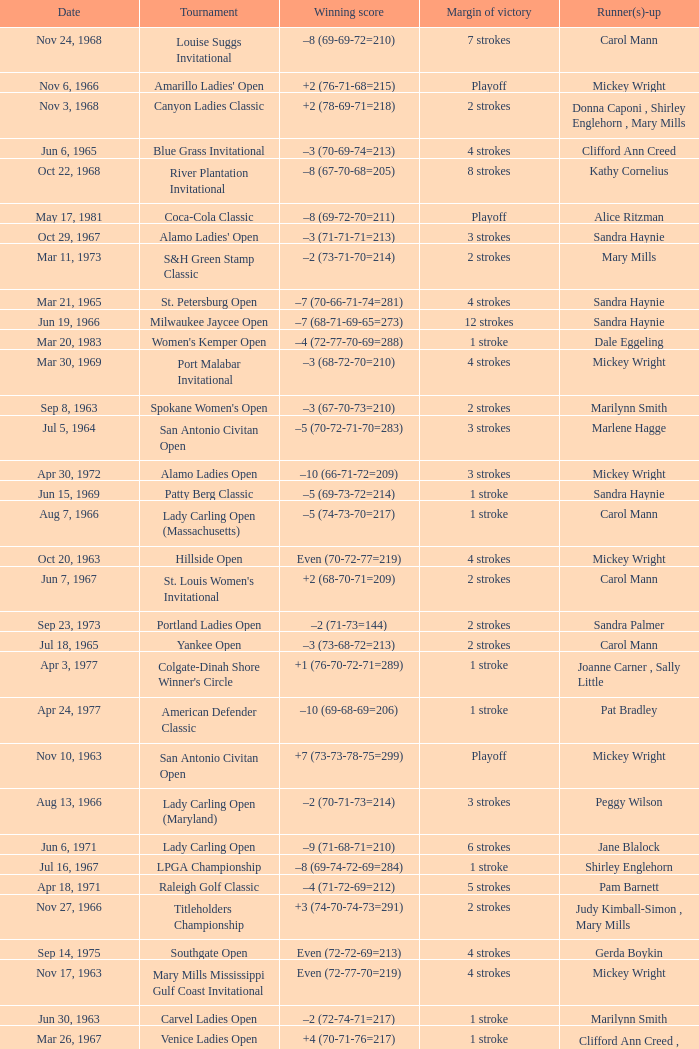Parse the table in full. {'header': ['Date', 'Tournament', 'Winning score', 'Margin of victory', 'Runner(s)-up'], 'rows': [['Nov 24, 1968', 'Louise Suggs Invitational', '–8 (69-69-72=210)', '7 strokes', 'Carol Mann'], ['Nov 6, 1966', "Amarillo Ladies' Open", '+2 (76-71-68=215)', 'Playoff', 'Mickey Wright'], ['Nov 3, 1968', 'Canyon Ladies Classic', '+2 (78-69-71=218)', '2 strokes', 'Donna Caponi , Shirley Englehorn , Mary Mills'], ['Jun 6, 1965', 'Blue Grass Invitational', '–3 (70-69-74=213)', '4 strokes', 'Clifford Ann Creed'], ['Oct 22, 1968', 'River Plantation Invitational', '–8 (67-70-68=205)', '8 strokes', 'Kathy Cornelius'], ['May 17, 1981', 'Coca-Cola Classic', '–8 (69-72-70=211)', 'Playoff', 'Alice Ritzman'], ['Oct 29, 1967', "Alamo Ladies' Open", '–3 (71-71-71=213)', '3 strokes', 'Sandra Haynie'], ['Mar 11, 1973', 'S&H Green Stamp Classic', '–2 (73-71-70=214)', '2 strokes', 'Mary Mills'], ['Mar 21, 1965', 'St. Petersburg Open', '–7 (70-66-71-74=281)', '4 strokes', 'Sandra Haynie'], ['Jun 19, 1966', 'Milwaukee Jaycee Open', '–7 (68-71-69-65=273)', '12 strokes', 'Sandra Haynie'], ['Mar 20, 1983', "Women's Kemper Open", '–4 (72-77-70-69=288)', '1 stroke', 'Dale Eggeling'], ['Mar 30, 1969', 'Port Malabar Invitational', '–3 (68-72-70=210)', '4 strokes', 'Mickey Wright'], ['Sep 8, 1963', "Spokane Women's Open", '–3 (67-70-73=210)', '2 strokes', 'Marilynn Smith'], ['Jul 5, 1964', 'San Antonio Civitan Open', '–5 (70-72-71-70=283)', '3 strokes', 'Marlene Hagge'], ['Apr 30, 1972', 'Alamo Ladies Open', '–10 (66-71-72=209)', '3 strokes', 'Mickey Wright'], ['Jun 15, 1969', 'Patty Berg Classic', '–5 (69-73-72=214)', '1 stroke', 'Sandra Haynie'], ['Aug 7, 1966', 'Lady Carling Open (Massachusetts)', '–5 (74-73-70=217)', '1 stroke', 'Carol Mann'], ['Oct 20, 1963', 'Hillside Open', 'Even (70-72-77=219)', '4 strokes', 'Mickey Wright'], ['Jun 7, 1967', "St. Louis Women's Invitational", '+2 (68-70-71=209)', '2 strokes', 'Carol Mann'], ['Sep 23, 1973', 'Portland Ladies Open', '–2 (71-73=144)', '2 strokes', 'Sandra Palmer'], ['Jul 18, 1965', 'Yankee Open', '–3 (73-68-72=213)', '2 strokes', 'Carol Mann'], ['Apr 3, 1977', "Colgate-Dinah Shore Winner's Circle", '+1 (76-70-72-71=289)', '1 stroke', 'Joanne Carner , Sally Little'], ['Apr 24, 1977', 'American Defender Classic', '–10 (69-68-69=206)', '1 stroke', 'Pat Bradley'], ['Nov 10, 1963', 'San Antonio Civitan Open', '+7 (73-73-78-75=299)', 'Playoff', 'Mickey Wright'], ['Aug 13, 1966', 'Lady Carling Open (Maryland)', '–2 (70-71-73=214)', '3 strokes', 'Peggy Wilson'], ['Jun 6, 1971', 'Lady Carling Open', '–9 (71-68-71=210)', '6 strokes', 'Jane Blalock'], ['Jul 16, 1967', 'LPGA Championship', '–8 (69-74-72-69=284)', '1 stroke', 'Shirley Englehorn'], ['Apr 18, 1971', 'Raleigh Golf Classic', '–4 (71-72-69=212)', '5 strokes', 'Pam Barnett'], ['Nov 27, 1966', 'Titleholders Championship', '+3 (74-70-74-73=291)', '2 strokes', 'Judy Kimball-Simon , Mary Mills'], ['Sep 14, 1975', 'Southgate Open', 'Even (72-72-69=213)', '4 strokes', 'Gerda Boykin'], ['Nov 17, 1963', 'Mary Mills Mississippi Gulf Coast Invitational', 'Even (72-77-70=219)', '4 strokes', 'Mickey Wright'], ['Jun 30, 1963', 'Carvel Ladies Open', '–2 (72-74-71=217)', '1 stroke', 'Marilynn Smith'], ['Mar 26, 1967', 'Venice Ladies Open', '+4 (70-71-76=217)', '1 stroke', 'Clifford Ann Creed , Gloria Ehret'], ['Aug 25, 1963', "Ogden Ladies' Open", '–5 (69-75-71=215)', '5 strokes', 'Mickey Wright'], ['Jul 8, 1962', 'Kelly Girls Open', '–7 (73-73-69=215)', '1 stroke', 'Sandra Haynie'], ['Jun 30, 1968', 'Lady Carling Open (Maryland)', '–2 (71-70-73=214)', '1 stroke', 'Carol Mann'], ['Nov 28, 1965', 'Titleholders Championship', '–1 (71-71-74-71=287)', '10 strokes', 'Peggy Wilson'], ['Mar 17, 1969', 'Orange Blossom Classic', '+3 (74-70-72=216)', 'Playoff', 'Shirley Englehorn , Marlene Hagge'], ['Jul 28, 1963', 'Wolverine Open', '–9 (72-64-62=198)', '5 strokes', 'Betsy Rawls'], ['Aug 20, 1972', 'Southgate Ladies Open', 'Even (69-71-76=216)', 'Playoff', 'Jocelyne Bourassa'], ['Mar 17, 1968', 'St. Petersburg Orange Blossom Open', 'Even (70-71-72=213)', '1 stroke', 'Sandra Haynie , Judy Kimball-Simon'], ['Jul 30, 1966', 'Supertest Ladies Open', '–3 (71-70-72=213)', '3 strokes', 'Mickey Wright'], ['May 26, 1968', 'Dallas Civitan Open', '–4 (70-70-69=209)', '1 stroke', 'Carol Mann'], ['Apr 23, 1967', 'Raleigh Ladies Invitational', '–1 (72-72-71=215)', '5 strokes', 'Susie Maxwell Berning'], ['Jul 23, 1972', 'Raleigh Golf Classic', '–4 (72-69-71=212)', '2 strokes', 'Marilynn Smith'], ['Apr 20, 1969', 'Lady Carling Open (Georgia)', '–4 (70-72-70=212)', 'Playoff', 'Mickey Wright'], ['Jun 5, 1966', 'Clayton Federal Invitational', '+1 (68-72-68=208)', '4 strokes', 'Shirley Englehorn'], ['Sep 16, 1984', 'Safeco Classic', '–9 (69-75-65-70=279)', '2 strokes', 'Laura Baugh , Marta Figueras-Dotti'], ['Sep 16, 1973', 'Southgate Ladies Open', '–2 (72-70=142)', '1 stroke', 'Gerda Boykin'], ['Nov 17, 1968', 'Pensacola Ladies Invitational', '–3 (71-71-74=216)', '3 strokes', 'Jo Ann Prentice ,'], ['Oct 1, 1972', 'Portland Ladies Open', '–7 (75-69-68=212)', '4 strokes', 'Sandra Haynie'], ['Apr 18, 1982', "CPC Women's International", '–7 (73-68-73-67=281)', '9 strokes', 'Patty Sheehan'], ['Nov 4, 1973', 'Lady Errol Classic', '–3 (68-75-70=213)', '2 strokes', 'Gloria Ehret , Shelley Hamlin'], ['Aug 18, 1968', 'Holiday Inn Classic', '–1 (74-70-62=206)', '3 strokes', 'Judy Kimball-Simon , Carol Mann'], ['Aug 6, 1972', 'Knoxville Ladies Classic', '–4 (71-68-71=210)', '4 strokes', 'Sandra Haynie'], ['May 16, 1982', 'Lady Michelob', '–9 (69-68-70=207)', '4 strokes', 'Sharon Barrett Barbara Moxness'], ['Oct 21, 1973', 'Waco Tribune Herald Ladies Classic', '–7 (68-72-69=209)', '4 strokes', 'Kathy Cornelius , Pam Higgins , Marilynn Smith'], ['Jul 25, 1965', 'Buckeye Savings Invitational', '–6 (70-67-70=207)', '1 stroke', 'Susan Maxwell-Berning'], ['Oct 14, 1962', 'Phoenix Thunderbird Open', '–3 (72-71-70=213)', '4 strokes', 'Mickey Wright'], ['Jun 1, 1975', 'LPGA Championship', '–4 (70-70-75-73=288)', '1 stroke', 'Sandra Haynie'], ['Jun 13, 1971', 'Eve-LPGA Championship', '–4 (71-73-70-74=288)', '4 strokes', 'Kathy Ahern'], ['Oct 3, 1965', 'Mickey Wright Invitational', '–9 (68-73-71-71=283)', '6 strokes', 'Donna Caponi'], ['Oct 18, 1970', "Quality Chek'd Classic", '–11 (71-67-67=205)', '3 strokes', 'JoAnne Carner'], ['Oct 30, 1966', 'Las Cruces Ladies Open', '–2 (69-71-74=214)', '6 strokes', 'Marilynn Smith'], ['Aug 22, 1976', 'Patty Berg Classic', '–7 (66-73-73=212)', '2 strokes', 'Sandra Post'], ['Aug 20, 1967', "Women's Western Open", '–11 (71-74-73-71=289)', '3 strokes', 'Sandra Haynie'], ['Jul 22, 1984', 'Rochester International', '–7 (73-68-71-69=281)', 'Playoff', 'Rosie Jones'], ['Sep 22, 1968', 'Kings River Open', '–8 (68-71-69=208)', '10 strokes', 'Sandra Haynie'], ['May 12, 1985', 'United Virginia Bank Classic', '–9 (69-66-72=207)', '1 stroke', 'Amy Alcott'], ['Aug 1, 1965', 'Lady Carling Midwest Open', 'Even (72-77-70=219)', '1 stroke', 'Sandra Haynie'], ['Aug 4, 1968', 'Gino Paoli Open', '–1 (69-72-74=215)', 'Playoff', 'Marlene Hagge'], ['Feb 7, 1976', 'Bent Tree Classic', '–7 (69-69-71=209)', '1 stroke', 'Hollis Stacy'], ['May 2, 1965', 'Shreveport Kiwanis Invitational', '–6 (70-70-70=210)', '6 strokes', 'Patty Berg'], ['May 22, 1977', 'LPGA Coca-Cola Classic', '–11 (67-68-67=202)', '3 strokes', 'Donna Caponi'], ['Feb 11, 1973', 'Naples Lely Classic', '+3 (68-76-75=219)', '2 strokes', 'JoAnne Carner'], ['Sep 10, 1978', 'National Jewish Hospital Open', '–5 (70-75-66-65=276)', '3 strokes', 'Pat Bradley , Gloria Ehret , JoAnn Washam'], ['Mar 22, 1970', 'Orange Blossom Classic', '+3 (73-72-71=216)', '1 stroke', 'Carol Mann'], ['Sep 14, 1969', 'Wendell-West Open', '–3 (69-72-72=213)', '1 stroke', 'Judy Rankin'], ['Nov 2, 1969', "River Plantation Women's Open", 'Even (70-71-72=213)', '1 stroke', 'Betsy Rawls'], ['Aug 4, 1963', 'Milwaukee Jaycee Open', '–2 (70-73-73-70=286)', '7 strokes', 'Jackie Pung , Louise Suggs'], ['Oct 1, 1967', "Ladies' Los Angeles Open", '–4 (71-68-73=212)', '4 strokes', 'Murle Breer'], ['Mar 23, 1969', 'Port Charlotte Invitational', '–1 (72-72-74=218)', '1 stroke', 'Sandra Haynie , Sandra Post'], ['Aug 6, 1967', 'Lady Carling Open (Ohio)', '–4 (71-70-71=212)', '1 stroke', 'Susie Maxwell Berning'], ['Oct 14, 1984', 'Smirnoff Ladies Irish Open', '–3 (70-74-69-72=285)', '2 strokes', 'Pat Bradley , Becky Pearson'], ['Sep 9, 1973', 'Dallas Civitan Open', '–3 (75-72-66=213)', 'Playoff', 'Mary Mills'], ['May 8, 1966', 'Tall City Open', '–5 (67-70-71=208)', '1 stroke', 'Mickey Wright'], ['May 23, 1971', 'Suzuki Golf Internationale', '+1 (72-72-73=217)', '2 strokes', 'Sandra Haynie , Sandra Palmer'], ['Mar 3, 1974', 'Orange Blossom Classic', '–7 (70-68-71=209)', '1 stroke', 'Sandra Haynie']]} What was the margin of victory on Apr 23, 1967? 5 strokes. 